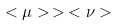Convert formula to latex. <formula><loc_0><loc_0><loc_500><loc_500>< \mu > \, > \, < \nu ></formula> 